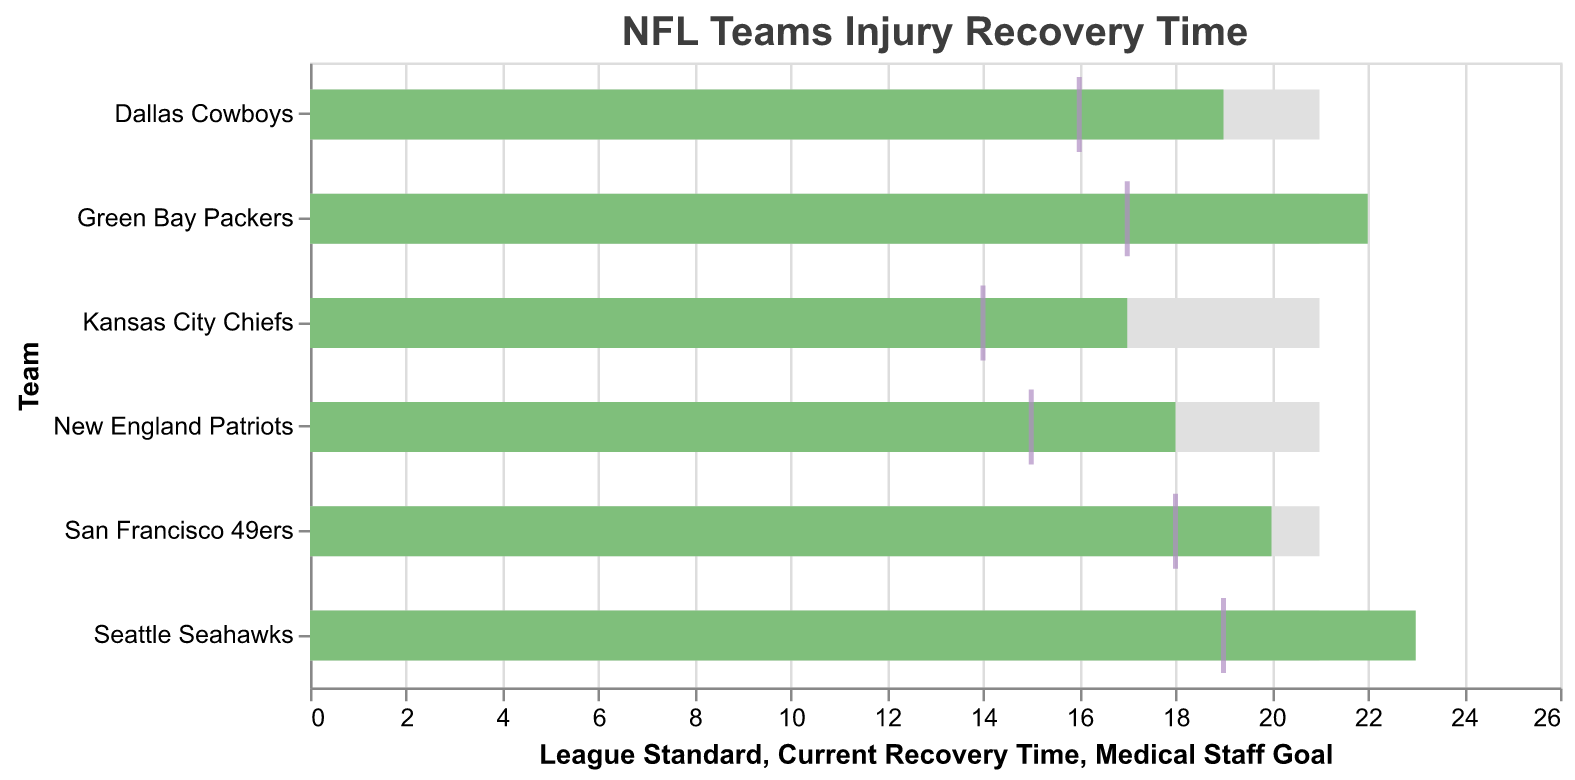What is the title of the chart? The title is typically displayed at the top of the chart and summarizes the topic of the data being visualized.
Answer: NFL Teams Injury Recovery Time Which team has the current recovery time that is equal to the league standard? By looking at the "Current Recovery Time" and comparing it to the "League Standard" bars, find where they match.
Answer: Dallas Cowboys Which team has the lowest recovery time? Identify the team with the shortest bar in the "Current Recovery Time" section.
Answer: Kansas City Chiefs How does the current recovery time of the Seattle Seahawks compare to the league standard? Compare the length of the bar representing the Seattle Seahawks' "Current Recovery Time" to the "League Standard" bar.
Answer: Greater than What is the difference between the current recovery time and the medical staff goal for the New England Patriots? Subtract the "Medical Staff Goal" from the "Current Recovery Time" for the New England Patriots. 18 - 15 = 3
Answer: 3 How many teams have recovery times lower than the league standard? Count the number of teams where the "Current Recovery Time" bar is shorter than the “League Standard” bar.
Answer: 3 Which team has the largest gap between their current recovery time and the medical staff goal? Calculate the differences for each team and compare them to find the largest one.
Answer: Seattle Seahawks What is the average current recovery time of all teams? Sum the current recovery times of all teams and divide by the number of teams: (18 + 22 + 19 + 20 + 17 + 23)/6 = 19.83
Answer: 19.83 Are there any teams meeting their medical staff goal? Check if any team's "Current Recovery Time" bar exactly aligns with the "Medical Staff Goal" tick.
Answer: No For which team is the current recovery time closest to the medical staff goal? Calculate the absolute difference between "Current Recovery Time" and "Medical Staff Goal" for each team and find the smallest difference.
Answer: San Francisco 49ers 